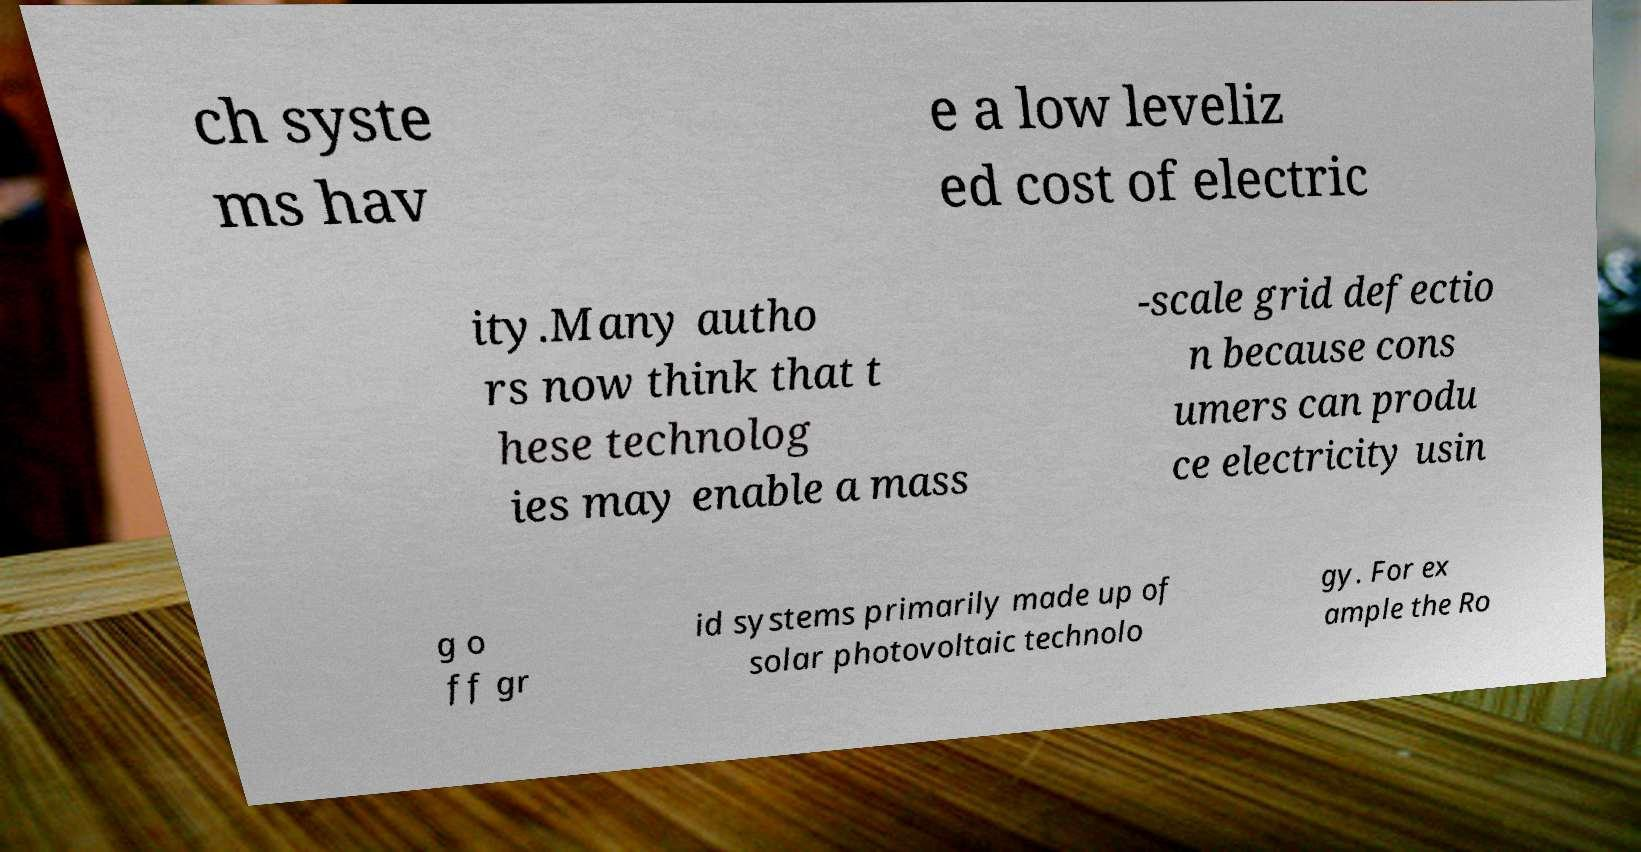For documentation purposes, I need the text within this image transcribed. Could you provide that? ch syste ms hav e a low leveliz ed cost of electric ity.Many autho rs now think that t hese technolog ies may enable a mass -scale grid defectio n because cons umers can produ ce electricity usin g o ff gr id systems primarily made up of solar photovoltaic technolo gy. For ex ample the Ro 